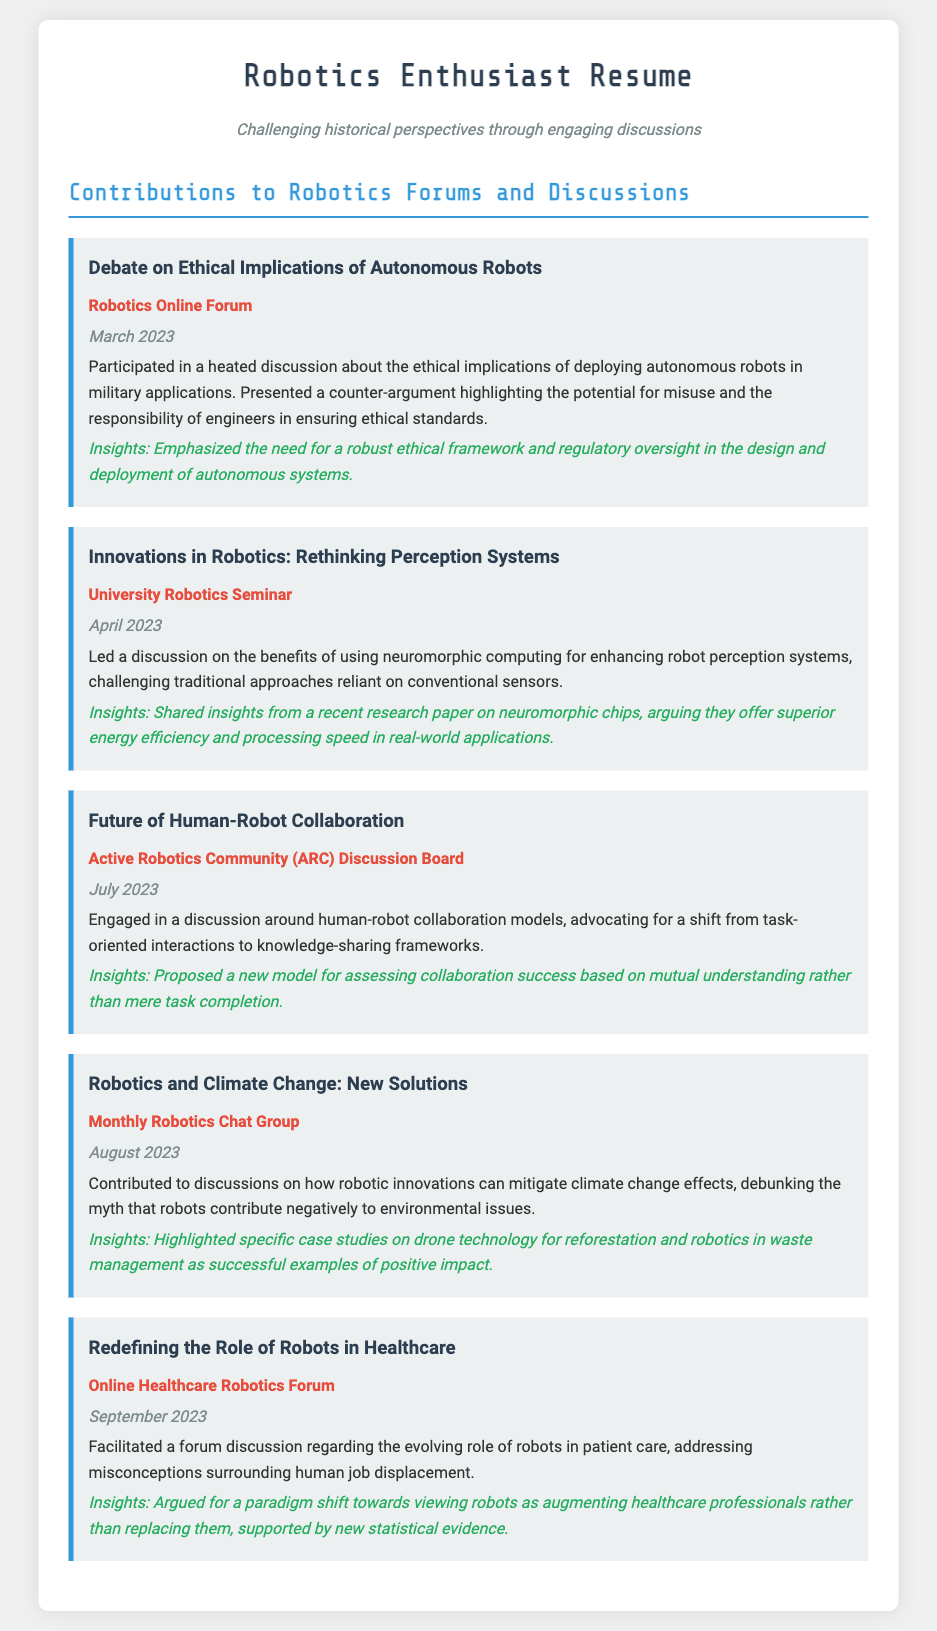What was the topic of discussion in March 2023? The topic was about the ethical implications of deploying autonomous robots in military applications.
Answer: Ethical Implications of Autonomous Robots Which forum hosted the discussion on neuromorphic computing? The discussion on neuromorphic computing was held at the University Robotics Seminar.
Answer: University Robotics Seminar What specific technology was highlighted regarding climate change? Drones were highlighted for their technology in reforestation.
Answer: Drone technology What was the proposed model for assessing collaboration success? The proposed model emphasized mutual understanding rather than mere task completion.
Answer: Mutual understanding In which month was the discussion on robotics and climate change held? The discussion on robotics and climate change took place in August 2023.
Answer: August 2023 What type of misconceptions were addressed in the healthcare robotics forum? The misconception addressed was surrounding human job displacement.
Answer: Human job displacement What was the primary focus of the discussion on human-robot collaboration? The focus was on shifting to knowledge-sharing frameworks.
Answer: Knowledge-sharing frameworks What is the key insight shared about autonomous systems? The key insight emphasized the need for a robust ethical framework and regulatory oversight.
Answer: Ethical framework and regulatory oversight Which community was mentioned for discussions on human-robot collaboration? The Active Robotics Community (ARC) Discussion Board was mentioned.
Answer: Active Robotics Community (ARC) 